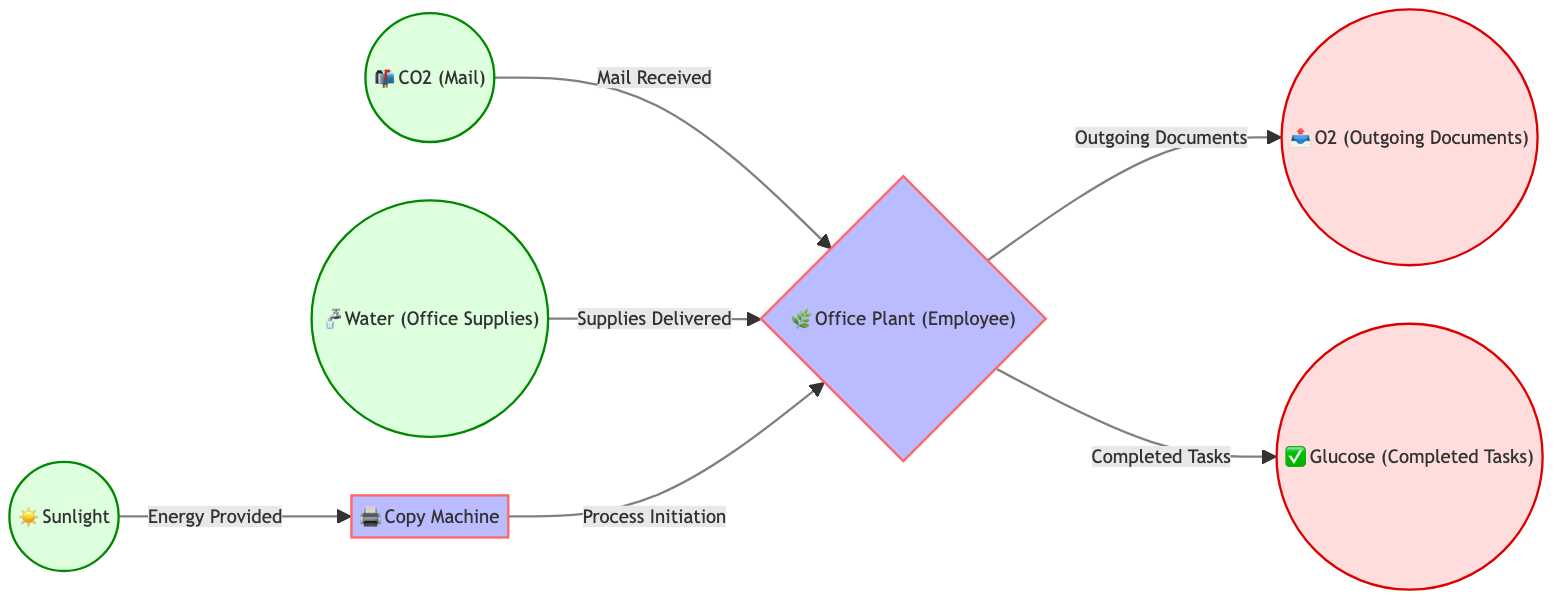What is the first input in the diagram? The diagram shows that the first input node is Sunlight, which is represented as "☀️ Sunlight." It is the starting point of the process, indicating energy provision.
Answer: Sunlight How many output nodes are there in the diagram? In the diagram, there are two output nodes: O2 (Outgoing Documents) and Glucose (Completed Tasks). Therefore, counting these nodes gives a total of two.
Answer: 2 What does the Office Plant produce? The Office Plant node has two outputs: O2 (Outgoing Documents) and Glucose (Completed Tasks). This indicates that the Office Plant produces both of these items as part of the process.
Answer: O2 and Glucose Which process initiates after receiving CO2? The diagram illustrates that after the Office Plant receives CO2, the next action is the initiation of the photocopy machine process, which is indicated by the arrow leading to the Office Plant.
Answer: Photocopy Machine What is the relationship between Water and Office Plant? The diagram shows that Water is provided to the Office Plant, indicated by the connection and the label "Supplies Delivered." This means that Water is one of the inputs necessary for the Office Plant to function.
Answer: Supplies Delivered What does the diagram compare the photocopy machine to? The diagram compares the photocopy machine to a process within an office workflow context, symbolizing the role it plays in photosynthesis. Specifically, it is likened to an office tool that helps in processing information through the plant.
Answer: Processing Tasks What role does the Office Plant serve in the diagram? The Office Plant acts as an employee who receives inputs (CO2 and Water) and subsequently performs tasks resulting in outputs (O2 and Glucose). This role aligns with the analogy of photosynthesis in a business workflow.
Answer: Employee How is energy provided to the photocopy machine? The diagram indicates that energy is provided to the photocopy machine through Sunlight, as depicted by the arrow connecting these two nodes. This indicates that without Sunlight, the photocopy machine would not function in this analogy.
Answer: Sunlight 